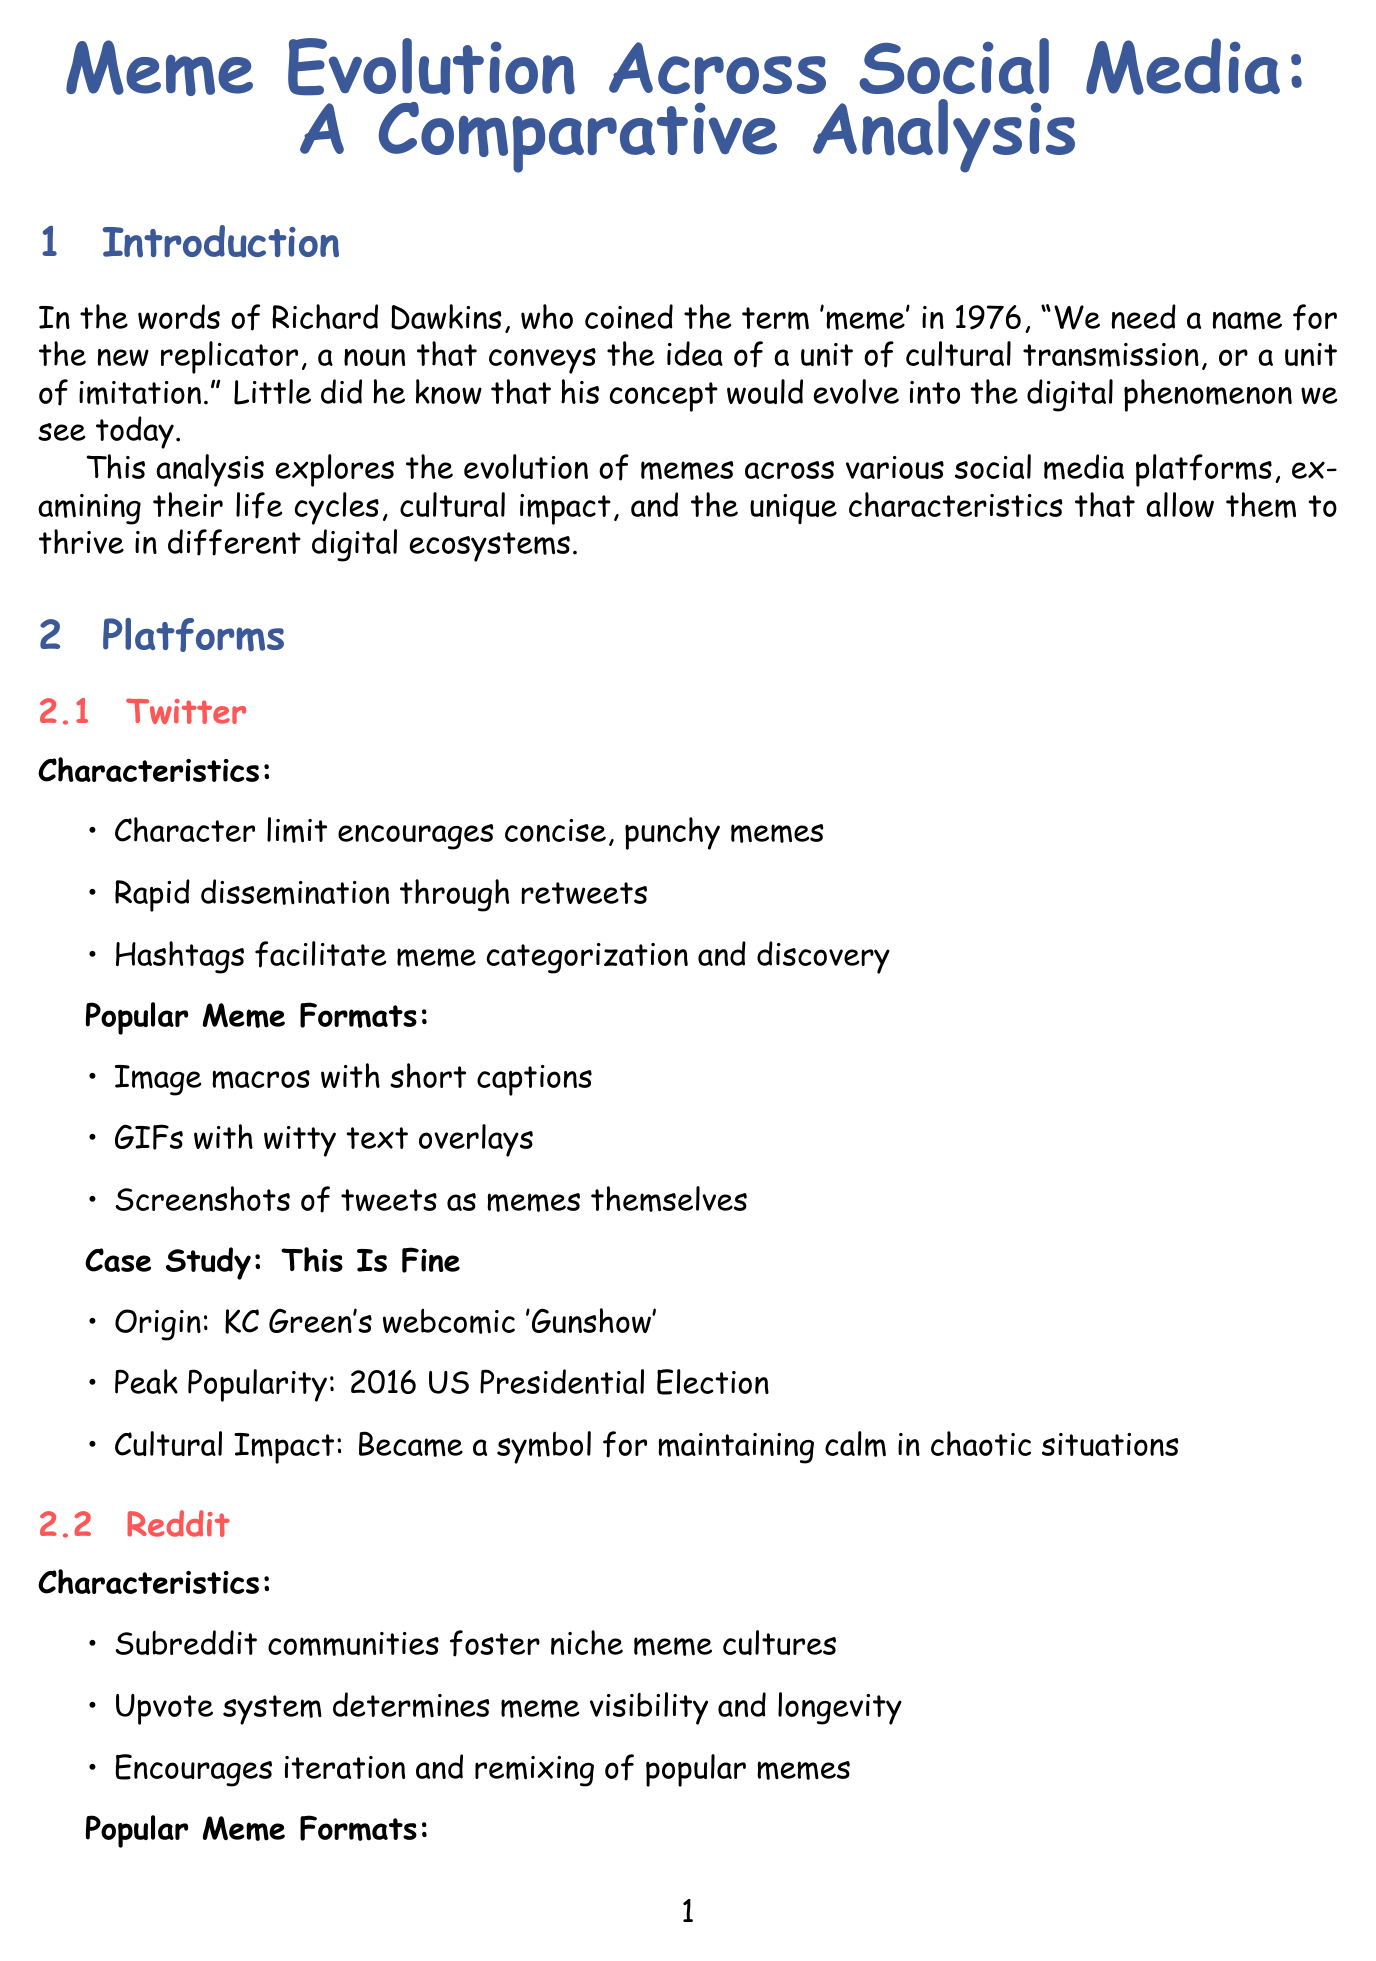What year did Richard Dawkins coin the term 'meme'? The document states that Richard Dawkins coined the term 'meme' in 1976.
Answer: 1976 What is the average lifespan of memes on Twitter? According to the document, the average lifespan of memes on Twitter is 3-5 days.
Answer: 3-5 days Which meme format is most popular on TikTok? The document indicates that short videos are the most popular meme format on TikTok, comprising 70% of the formats.
Answer: Short videos What meme originated from KC Green's webcomic 'Gunshow'? The case study in the document mentions that "This Is Fine" originated from KC Green's webcomic 'Gunshow'.
Answer: This Is Fine What was the cultural impact of the "Renegade Dance"? The document describes the cultural impact of the "Renegade Dance" as sparking discussions about proper attribution in meme culture.
Answer: Sparked discussions about proper attribution How did the "Distracted Boyfriend" meme migrate across platforms? The document details that the "Distracted Boyfriend" meme initially gained traction on Twitter, exploded on Reddit, and adapted for TikTok.
Answer: Twitter to Reddit to TikTok During which event did "Tiger King" memes become popular? The document notes that "Tiger King" memes became popular during the COVID-19 Pandemic.
Answer: COVID-19 Pandemic 